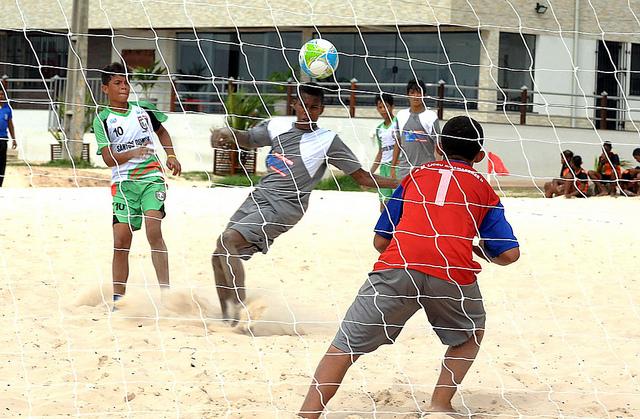What is the name of the sport these people are playing?
Concise answer only. Volleyball. Who has a shirt with number 1?
Concise answer only. Goalie. What number is victor's Jersey?
Be succinct. 1. What color is the ball?
Give a very brief answer. White, green and blue. How old are the boys?
Keep it brief. 10. 